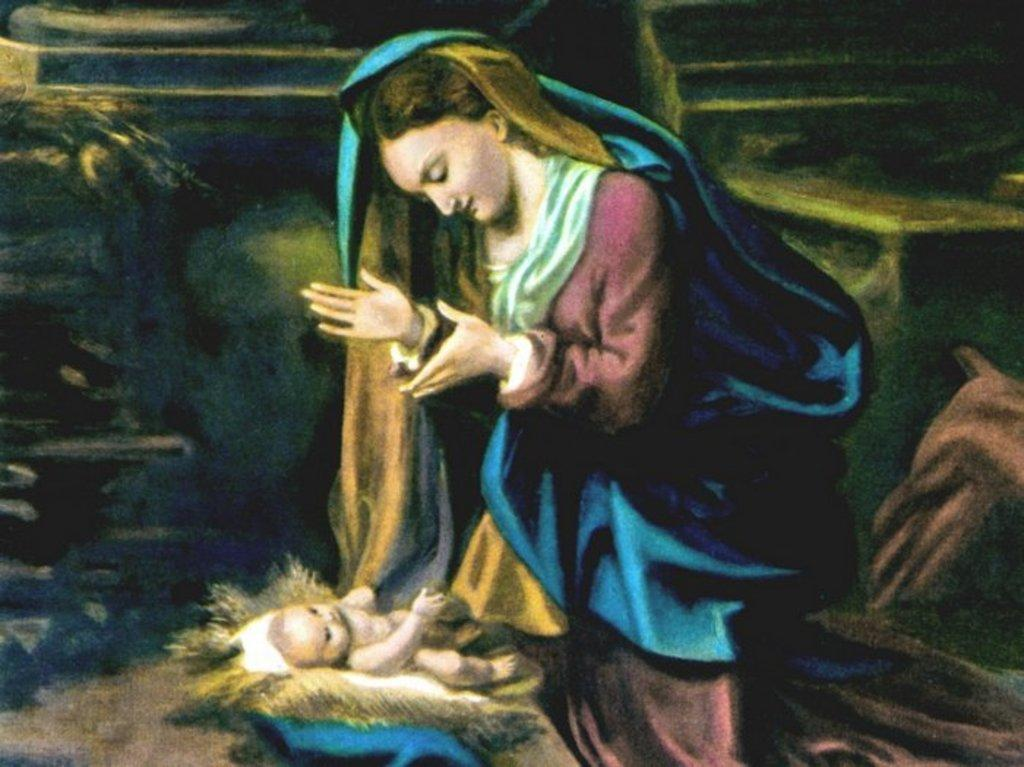What is the main subject of the image? There is a person depicted in the image. Can you describe the person's attire? The person is wearing clothes. What other figure can be seen in the image? There is a baby at the bottom of the image. What type of pan is being used to cook the wine in the image? There is no pan or wine present in the image; it only features a person and a baby. 